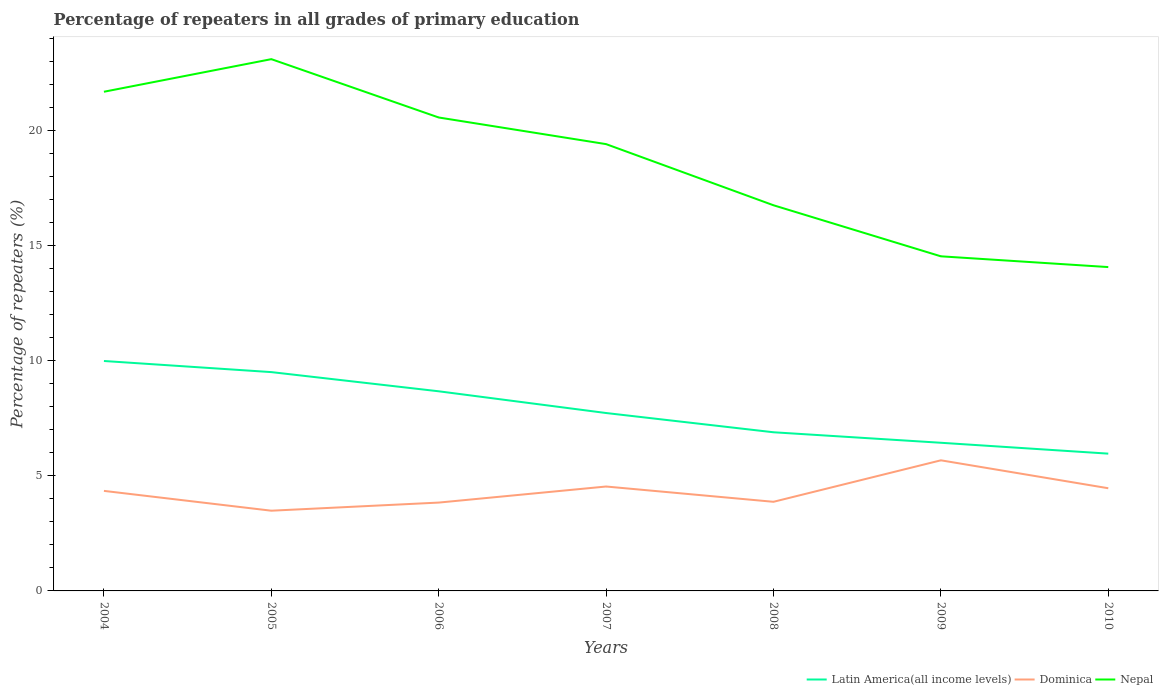How many different coloured lines are there?
Your answer should be very brief. 3. Is the number of lines equal to the number of legend labels?
Provide a succinct answer. Yes. Across all years, what is the maximum percentage of repeaters in Dominica?
Your answer should be compact. 3.48. In which year was the percentage of repeaters in Latin America(all income levels) maximum?
Your response must be concise. 2010. What is the total percentage of repeaters in Dominica in the graph?
Your response must be concise. 0.47. What is the difference between the highest and the second highest percentage of repeaters in Nepal?
Provide a succinct answer. 9.03. What is the difference between the highest and the lowest percentage of repeaters in Latin America(all income levels)?
Keep it short and to the point. 3. How many lines are there?
Your response must be concise. 3. How many years are there in the graph?
Make the answer very short. 7. What is the difference between two consecutive major ticks on the Y-axis?
Your answer should be compact. 5. Does the graph contain any zero values?
Provide a succinct answer. No. Where does the legend appear in the graph?
Your answer should be very brief. Bottom right. How many legend labels are there?
Give a very brief answer. 3. How are the legend labels stacked?
Provide a short and direct response. Horizontal. What is the title of the graph?
Your response must be concise. Percentage of repeaters in all grades of primary education. What is the label or title of the X-axis?
Provide a succinct answer. Years. What is the label or title of the Y-axis?
Keep it short and to the point. Percentage of repeaters (%). What is the Percentage of repeaters (%) in Latin America(all income levels) in 2004?
Your response must be concise. 9.99. What is the Percentage of repeaters (%) in Dominica in 2004?
Provide a succinct answer. 4.35. What is the Percentage of repeaters (%) in Nepal in 2004?
Offer a terse response. 21.68. What is the Percentage of repeaters (%) of Latin America(all income levels) in 2005?
Offer a very short reply. 9.51. What is the Percentage of repeaters (%) in Dominica in 2005?
Provide a succinct answer. 3.48. What is the Percentage of repeaters (%) in Nepal in 2005?
Ensure brevity in your answer.  23.1. What is the Percentage of repeaters (%) in Latin America(all income levels) in 2006?
Offer a very short reply. 8.67. What is the Percentage of repeaters (%) in Dominica in 2006?
Your response must be concise. 3.84. What is the Percentage of repeaters (%) of Nepal in 2006?
Ensure brevity in your answer.  20.57. What is the Percentage of repeaters (%) in Latin America(all income levels) in 2007?
Offer a terse response. 7.73. What is the Percentage of repeaters (%) of Dominica in 2007?
Keep it short and to the point. 4.54. What is the Percentage of repeaters (%) in Nepal in 2007?
Ensure brevity in your answer.  19.41. What is the Percentage of repeaters (%) of Latin America(all income levels) in 2008?
Ensure brevity in your answer.  6.89. What is the Percentage of repeaters (%) in Dominica in 2008?
Your answer should be compact. 3.87. What is the Percentage of repeaters (%) in Nepal in 2008?
Ensure brevity in your answer.  16.75. What is the Percentage of repeaters (%) of Latin America(all income levels) in 2009?
Your response must be concise. 6.44. What is the Percentage of repeaters (%) in Dominica in 2009?
Keep it short and to the point. 5.67. What is the Percentage of repeaters (%) of Nepal in 2009?
Give a very brief answer. 14.54. What is the Percentage of repeaters (%) of Latin America(all income levels) in 2010?
Ensure brevity in your answer.  5.96. What is the Percentage of repeaters (%) of Dominica in 2010?
Offer a terse response. 4.46. What is the Percentage of repeaters (%) of Nepal in 2010?
Offer a terse response. 14.07. Across all years, what is the maximum Percentage of repeaters (%) in Latin America(all income levels)?
Offer a very short reply. 9.99. Across all years, what is the maximum Percentage of repeaters (%) of Dominica?
Provide a short and direct response. 5.67. Across all years, what is the maximum Percentage of repeaters (%) of Nepal?
Your answer should be compact. 23.1. Across all years, what is the minimum Percentage of repeaters (%) of Latin America(all income levels)?
Provide a short and direct response. 5.96. Across all years, what is the minimum Percentage of repeaters (%) of Dominica?
Make the answer very short. 3.48. Across all years, what is the minimum Percentage of repeaters (%) of Nepal?
Offer a very short reply. 14.07. What is the total Percentage of repeaters (%) in Latin America(all income levels) in the graph?
Your answer should be very brief. 55.19. What is the total Percentage of repeaters (%) in Dominica in the graph?
Provide a short and direct response. 30.21. What is the total Percentage of repeaters (%) of Nepal in the graph?
Provide a succinct answer. 130.12. What is the difference between the Percentage of repeaters (%) in Latin America(all income levels) in 2004 and that in 2005?
Make the answer very short. 0.48. What is the difference between the Percentage of repeaters (%) in Dominica in 2004 and that in 2005?
Your response must be concise. 0.86. What is the difference between the Percentage of repeaters (%) of Nepal in 2004 and that in 2005?
Keep it short and to the point. -1.42. What is the difference between the Percentage of repeaters (%) in Latin America(all income levels) in 2004 and that in 2006?
Keep it short and to the point. 1.32. What is the difference between the Percentage of repeaters (%) of Dominica in 2004 and that in 2006?
Make the answer very short. 0.51. What is the difference between the Percentage of repeaters (%) of Nepal in 2004 and that in 2006?
Keep it short and to the point. 1.12. What is the difference between the Percentage of repeaters (%) of Latin America(all income levels) in 2004 and that in 2007?
Make the answer very short. 2.26. What is the difference between the Percentage of repeaters (%) of Dominica in 2004 and that in 2007?
Give a very brief answer. -0.19. What is the difference between the Percentage of repeaters (%) in Nepal in 2004 and that in 2007?
Offer a terse response. 2.28. What is the difference between the Percentage of repeaters (%) in Latin America(all income levels) in 2004 and that in 2008?
Keep it short and to the point. 3.1. What is the difference between the Percentage of repeaters (%) in Dominica in 2004 and that in 2008?
Offer a terse response. 0.47. What is the difference between the Percentage of repeaters (%) in Nepal in 2004 and that in 2008?
Offer a very short reply. 4.93. What is the difference between the Percentage of repeaters (%) in Latin America(all income levels) in 2004 and that in 2009?
Your answer should be compact. 3.55. What is the difference between the Percentage of repeaters (%) in Dominica in 2004 and that in 2009?
Your response must be concise. -1.33. What is the difference between the Percentage of repeaters (%) in Nepal in 2004 and that in 2009?
Your answer should be compact. 7.15. What is the difference between the Percentage of repeaters (%) of Latin America(all income levels) in 2004 and that in 2010?
Your response must be concise. 4.02. What is the difference between the Percentage of repeaters (%) in Dominica in 2004 and that in 2010?
Make the answer very short. -0.11. What is the difference between the Percentage of repeaters (%) in Nepal in 2004 and that in 2010?
Provide a succinct answer. 7.62. What is the difference between the Percentage of repeaters (%) of Latin America(all income levels) in 2005 and that in 2006?
Your response must be concise. 0.83. What is the difference between the Percentage of repeaters (%) of Dominica in 2005 and that in 2006?
Your answer should be very brief. -0.35. What is the difference between the Percentage of repeaters (%) of Nepal in 2005 and that in 2006?
Make the answer very short. 2.53. What is the difference between the Percentage of repeaters (%) of Latin America(all income levels) in 2005 and that in 2007?
Give a very brief answer. 1.78. What is the difference between the Percentage of repeaters (%) in Dominica in 2005 and that in 2007?
Offer a very short reply. -1.05. What is the difference between the Percentage of repeaters (%) in Nepal in 2005 and that in 2007?
Your response must be concise. 3.69. What is the difference between the Percentage of repeaters (%) of Latin America(all income levels) in 2005 and that in 2008?
Your answer should be very brief. 2.61. What is the difference between the Percentage of repeaters (%) in Dominica in 2005 and that in 2008?
Provide a succinct answer. -0.39. What is the difference between the Percentage of repeaters (%) in Nepal in 2005 and that in 2008?
Your answer should be very brief. 6.35. What is the difference between the Percentage of repeaters (%) of Latin America(all income levels) in 2005 and that in 2009?
Your answer should be very brief. 3.07. What is the difference between the Percentage of repeaters (%) of Dominica in 2005 and that in 2009?
Provide a short and direct response. -2.19. What is the difference between the Percentage of repeaters (%) of Nepal in 2005 and that in 2009?
Make the answer very short. 8.57. What is the difference between the Percentage of repeaters (%) in Latin America(all income levels) in 2005 and that in 2010?
Your answer should be compact. 3.54. What is the difference between the Percentage of repeaters (%) in Dominica in 2005 and that in 2010?
Your answer should be compact. -0.98. What is the difference between the Percentage of repeaters (%) of Nepal in 2005 and that in 2010?
Provide a succinct answer. 9.03. What is the difference between the Percentage of repeaters (%) of Latin America(all income levels) in 2006 and that in 2007?
Give a very brief answer. 0.94. What is the difference between the Percentage of repeaters (%) of Dominica in 2006 and that in 2007?
Ensure brevity in your answer.  -0.7. What is the difference between the Percentage of repeaters (%) in Nepal in 2006 and that in 2007?
Provide a succinct answer. 1.16. What is the difference between the Percentage of repeaters (%) in Latin America(all income levels) in 2006 and that in 2008?
Offer a terse response. 1.78. What is the difference between the Percentage of repeaters (%) of Dominica in 2006 and that in 2008?
Offer a very short reply. -0.03. What is the difference between the Percentage of repeaters (%) of Nepal in 2006 and that in 2008?
Your answer should be very brief. 3.81. What is the difference between the Percentage of repeaters (%) in Latin America(all income levels) in 2006 and that in 2009?
Offer a very short reply. 2.24. What is the difference between the Percentage of repeaters (%) in Dominica in 2006 and that in 2009?
Offer a terse response. -1.84. What is the difference between the Percentage of repeaters (%) in Nepal in 2006 and that in 2009?
Offer a very short reply. 6.03. What is the difference between the Percentage of repeaters (%) of Latin America(all income levels) in 2006 and that in 2010?
Offer a terse response. 2.71. What is the difference between the Percentage of repeaters (%) in Dominica in 2006 and that in 2010?
Offer a terse response. -0.62. What is the difference between the Percentage of repeaters (%) of Nepal in 2006 and that in 2010?
Your answer should be compact. 6.5. What is the difference between the Percentage of repeaters (%) of Latin America(all income levels) in 2007 and that in 2008?
Keep it short and to the point. 0.84. What is the difference between the Percentage of repeaters (%) in Dominica in 2007 and that in 2008?
Your response must be concise. 0.66. What is the difference between the Percentage of repeaters (%) in Nepal in 2007 and that in 2008?
Offer a terse response. 2.66. What is the difference between the Percentage of repeaters (%) of Latin America(all income levels) in 2007 and that in 2009?
Make the answer very short. 1.29. What is the difference between the Percentage of repeaters (%) in Dominica in 2007 and that in 2009?
Offer a very short reply. -1.14. What is the difference between the Percentage of repeaters (%) of Nepal in 2007 and that in 2009?
Ensure brevity in your answer.  4.87. What is the difference between the Percentage of repeaters (%) in Latin America(all income levels) in 2007 and that in 2010?
Your response must be concise. 1.76. What is the difference between the Percentage of repeaters (%) of Dominica in 2007 and that in 2010?
Provide a short and direct response. 0.07. What is the difference between the Percentage of repeaters (%) in Nepal in 2007 and that in 2010?
Offer a very short reply. 5.34. What is the difference between the Percentage of repeaters (%) in Latin America(all income levels) in 2008 and that in 2009?
Offer a terse response. 0.46. What is the difference between the Percentage of repeaters (%) of Dominica in 2008 and that in 2009?
Make the answer very short. -1.8. What is the difference between the Percentage of repeaters (%) of Nepal in 2008 and that in 2009?
Offer a terse response. 2.22. What is the difference between the Percentage of repeaters (%) of Latin America(all income levels) in 2008 and that in 2010?
Give a very brief answer. 0.93. What is the difference between the Percentage of repeaters (%) of Dominica in 2008 and that in 2010?
Provide a short and direct response. -0.59. What is the difference between the Percentage of repeaters (%) in Nepal in 2008 and that in 2010?
Provide a succinct answer. 2.69. What is the difference between the Percentage of repeaters (%) of Latin America(all income levels) in 2009 and that in 2010?
Your response must be concise. 0.47. What is the difference between the Percentage of repeaters (%) of Dominica in 2009 and that in 2010?
Your response must be concise. 1.21. What is the difference between the Percentage of repeaters (%) of Nepal in 2009 and that in 2010?
Give a very brief answer. 0.47. What is the difference between the Percentage of repeaters (%) of Latin America(all income levels) in 2004 and the Percentage of repeaters (%) of Dominica in 2005?
Your answer should be very brief. 6.5. What is the difference between the Percentage of repeaters (%) of Latin America(all income levels) in 2004 and the Percentage of repeaters (%) of Nepal in 2005?
Offer a terse response. -13.11. What is the difference between the Percentage of repeaters (%) of Dominica in 2004 and the Percentage of repeaters (%) of Nepal in 2005?
Keep it short and to the point. -18.76. What is the difference between the Percentage of repeaters (%) of Latin America(all income levels) in 2004 and the Percentage of repeaters (%) of Dominica in 2006?
Give a very brief answer. 6.15. What is the difference between the Percentage of repeaters (%) of Latin America(all income levels) in 2004 and the Percentage of repeaters (%) of Nepal in 2006?
Keep it short and to the point. -10.58. What is the difference between the Percentage of repeaters (%) in Dominica in 2004 and the Percentage of repeaters (%) in Nepal in 2006?
Your response must be concise. -16.22. What is the difference between the Percentage of repeaters (%) in Latin America(all income levels) in 2004 and the Percentage of repeaters (%) in Dominica in 2007?
Offer a terse response. 5.45. What is the difference between the Percentage of repeaters (%) of Latin America(all income levels) in 2004 and the Percentage of repeaters (%) of Nepal in 2007?
Make the answer very short. -9.42. What is the difference between the Percentage of repeaters (%) in Dominica in 2004 and the Percentage of repeaters (%) in Nepal in 2007?
Offer a terse response. -15.06. What is the difference between the Percentage of repeaters (%) of Latin America(all income levels) in 2004 and the Percentage of repeaters (%) of Dominica in 2008?
Your answer should be very brief. 6.12. What is the difference between the Percentage of repeaters (%) in Latin America(all income levels) in 2004 and the Percentage of repeaters (%) in Nepal in 2008?
Offer a very short reply. -6.76. What is the difference between the Percentage of repeaters (%) in Dominica in 2004 and the Percentage of repeaters (%) in Nepal in 2008?
Provide a succinct answer. -12.41. What is the difference between the Percentage of repeaters (%) in Latin America(all income levels) in 2004 and the Percentage of repeaters (%) in Dominica in 2009?
Your answer should be very brief. 4.31. What is the difference between the Percentage of repeaters (%) in Latin America(all income levels) in 2004 and the Percentage of repeaters (%) in Nepal in 2009?
Give a very brief answer. -4.55. What is the difference between the Percentage of repeaters (%) of Dominica in 2004 and the Percentage of repeaters (%) of Nepal in 2009?
Provide a succinct answer. -10.19. What is the difference between the Percentage of repeaters (%) in Latin America(all income levels) in 2004 and the Percentage of repeaters (%) in Dominica in 2010?
Your answer should be very brief. 5.53. What is the difference between the Percentage of repeaters (%) of Latin America(all income levels) in 2004 and the Percentage of repeaters (%) of Nepal in 2010?
Keep it short and to the point. -4.08. What is the difference between the Percentage of repeaters (%) in Dominica in 2004 and the Percentage of repeaters (%) in Nepal in 2010?
Provide a succinct answer. -9.72. What is the difference between the Percentage of repeaters (%) in Latin America(all income levels) in 2005 and the Percentage of repeaters (%) in Dominica in 2006?
Keep it short and to the point. 5.67. What is the difference between the Percentage of repeaters (%) of Latin America(all income levels) in 2005 and the Percentage of repeaters (%) of Nepal in 2006?
Make the answer very short. -11.06. What is the difference between the Percentage of repeaters (%) in Dominica in 2005 and the Percentage of repeaters (%) in Nepal in 2006?
Your response must be concise. -17.08. What is the difference between the Percentage of repeaters (%) of Latin America(all income levels) in 2005 and the Percentage of repeaters (%) of Dominica in 2007?
Give a very brief answer. 4.97. What is the difference between the Percentage of repeaters (%) of Latin America(all income levels) in 2005 and the Percentage of repeaters (%) of Nepal in 2007?
Your answer should be compact. -9.9. What is the difference between the Percentage of repeaters (%) of Dominica in 2005 and the Percentage of repeaters (%) of Nepal in 2007?
Keep it short and to the point. -15.92. What is the difference between the Percentage of repeaters (%) of Latin America(all income levels) in 2005 and the Percentage of repeaters (%) of Dominica in 2008?
Provide a short and direct response. 5.63. What is the difference between the Percentage of repeaters (%) in Latin America(all income levels) in 2005 and the Percentage of repeaters (%) in Nepal in 2008?
Ensure brevity in your answer.  -7.25. What is the difference between the Percentage of repeaters (%) of Dominica in 2005 and the Percentage of repeaters (%) of Nepal in 2008?
Make the answer very short. -13.27. What is the difference between the Percentage of repeaters (%) of Latin America(all income levels) in 2005 and the Percentage of repeaters (%) of Dominica in 2009?
Your answer should be very brief. 3.83. What is the difference between the Percentage of repeaters (%) in Latin America(all income levels) in 2005 and the Percentage of repeaters (%) in Nepal in 2009?
Your answer should be compact. -5.03. What is the difference between the Percentage of repeaters (%) in Dominica in 2005 and the Percentage of repeaters (%) in Nepal in 2009?
Give a very brief answer. -11.05. What is the difference between the Percentage of repeaters (%) in Latin America(all income levels) in 2005 and the Percentage of repeaters (%) in Dominica in 2010?
Your response must be concise. 5.04. What is the difference between the Percentage of repeaters (%) in Latin America(all income levels) in 2005 and the Percentage of repeaters (%) in Nepal in 2010?
Offer a terse response. -4.56. What is the difference between the Percentage of repeaters (%) in Dominica in 2005 and the Percentage of repeaters (%) in Nepal in 2010?
Offer a terse response. -10.58. What is the difference between the Percentage of repeaters (%) of Latin America(all income levels) in 2006 and the Percentage of repeaters (%) of Dominica in 2007?
Your answer should be compact. 4.14. What is the difference between the Percentage of repeaters (%) in Latin America(all income levels) in 2006 and the Percentage of repeaters (%) in Nepal in 2007?
Give a very brief answer. -10.74. What is the difference between the Percentage of repeaters (%) of Dominica in 2006 and the Percentage of repeaters (%) of Nepal in 2007?
Offer a terse response. -15.57. What is the difference between the Percentage of repeaters (%) of Latin America(all income levels) in 2006 and the Percentage of repeaters (%) of Dominica in 2008?
Provide a short and direct response. 4.8. What is the difference between the Percentage of repeaters (%) in Latin America(all income levels) in 2006 and the Percentage of repeaters (%) in Nepal in 2008?
Provide a short and direct response. -8.08. What is the difference between the Percentage of repeaters (%) of Dominica in 2006 and the Percentage of repeaters (%) of Nepal in 2008?
Provide a short and direct response. -12.92. What is the difference between the Percentage of repeaters (%) of Latin America(all income levels) in 2006 and the Percentage of repeaters (%) of Dominica in 2009?
Keep it short and to the point. 3. What is the difference between the Percentage of repeaters (%) of Latin America(all income levels) in 2006 and the Percentage of repeaters (%) of Nepal in 2009?
Provide a succinct answer. -5.86. What is the difference between the Percentage of repeaters (%) of Dominica in 2006 and the Percentage of repeaters (%) of Nepal in 2009?
Ensure brevity in your answer.  -10.7. What is the difference between the Percentage of repeaters (%) of Latin America(all income levels) in 2006 and the Percentage of repeaters (%) of Dominica in 2010?
Your response must be concise. 4.21. What is the difference between the Percentage of repeaters (%) in Latin America(all income levels) in 2006 and the Percentage of repeaters (%) in Nepal in 2010?
Provide a succinct answer. -5.4. What is the difference between the Percentage of repeaters (%) in Dominica in 2006 and the Percentage of repeaters (%) in Nepal in 2010?
Make the answer very short. -10.23. What is the difference between the Percentage of repeaters (%) in Latin America(all income levels) in 2007 and the Percentage of repeaters (%) in Dominica in 2008?
Your response must be concise. 3.86. What is the difference between the Percentage of repeaters (%) in Latin America(all income levels) in 2007 and the Percentage of repeaters (%) in Nepal in 2008?
Keep it short and to the point. -9.03. What is the difference between the Percentage of repeaters (%) of Dominica in 2007 and the Percentage of repeaters (%) of Nepal in 2008?
Keep it short and to the point. -12.22. What is the difference between the Percentage of repeaters (%) in Latin America(all income levels) in 2007 and the Percentage of repeaters (%) in Dominica in 2009?
Ensure brevity in your answer.  2.05. What is the difference between the Percentage of repeaters (%) of Latin America(all income levels) in 2007 and the Percentage of repeaters (%) of Nepal in 2009?
Your answer should be compact. -6.81. What is the difference between the Percentage of repeaters (%) of Dominica in 2007 and the Percentage of repeaters (%) of Nepal in 2009?
Give a very brief answer. -10. What is the difference between the Percentage of repeaters (%) of Latin America(all income levels) in 2007 and the Percentage of repeaters (%) of Dominica in 2010?
Your answer should be very brief. 3.27. What is the difference between the Percentage of repeaters (%) of Latin America(all income levels) in 2007 and the Percentage of repeaters (%) of Nepal in 2010?
Make the answer very short. -6.34. What is the difference between the Percentage of repeaters (%) of Dominica in 2007 and the Percentage of repeaters (%) of Nepal in 2010?
Give a very brief answer. -9.53. What is the difference between the Percentage of repeaters (%) of Latin America(all income levels) in 2008 and the Percentage of repeaters (%) of Dominica in 2009?
Provide a short and direct response. 1.22. What is the difference between the Percentage of repeaters (%) in Latin America(all income levels) in 2008 and the Percentage of repeaters (%) in Nepal in 2009?
Provide a succinct answer. -7.64. What is the difference between the Percentage of repeaters (%) in Dominica in 2008 and the Percentage of repeaters (%) in Nepal in 2009?
Give a very brief answer. -10.66. What is the difference between the Percentage of repeaters (%) of Latin America(all income levels) in 2008 and the Percentage of repeaters (%) of Dominica in 2010?
Offer a terse response. 2.43. What is the difference between the Percentage of repeaters (%) in Latin America(all income levels) in 2008 and the Percentage of repeaters (%) in Nepal in 2010?
Provide a succinct answer. -7.18. What is the difference between the Percentage of repeaters (%) of Dominica in 2008 and the Percentage of repeaters (%) of Nepal in 2010?
Your answer should be very brief. -10.2. What is the difference between the Percentage of repeaters (%) of Latin America(all income levels) in 2009 and the Percentage of repeaters (%) of Dominica in 2010?
Ensure brevity in your answer.  1.98. What is the difference between the Percentage of repeaters (%) of Latin America(all income levels) in 2009 and the Percentage of repeaters (%) of Nepal in 2010?
Provide a short and direct response. -7.63. What is the difference between the Percentage of repeaters (%) in Dominica in 2009 and the Percentage of repeaters (%) in Nepal in 2010?
Offer a very short reply. -8.39. What is the average Percentage of repeaters (%) in Latin America(all income levels) per year?
Offer a very short reply. 7.88. What is the average Percentage of repeaters (%) of Dominica per year?
Make the answer very short. 4.32. What is the average Percentage of repeaters (%) of Nepal per year?
Offer a very short reply. 18.59. In the year 2004, what is the difference between the Percentage of repeaters (%) of Latin America(all income levels) and Percentage of repeaters (%) of Dominica?
Ensure brevity in your answer.  5.64. In the year 2004, what is the difference between the Percentage of repeaters (%) of Latin America(all income levels) and Percentage of repeaters (%) of Nepal?
Give a very brief answer. -11.7. In the year 2004, what is the difference between the Percentage of repeaters (%) in Dominica and Percentage of repeaters (%) in Nepal?
Your answer should be compact. -17.34. In the year 2005, what is the difference between the Percentage of repeaters (%) in Latin America(all income levels) and Percentage of repeaters (%) in Dominica?
Offer a terse response. 6.02. In the year 2005, what is the difference between the Percentage of repeaters (%) of Latin America(all income levels) and Percentage of repeaters (%) of Nepal?
Ensure brevity in your answer.  -13.6. In the year 2005, what is the difference between the Percentage of repeaters (%) in Dominica and Percentage of repeaters (%) in Nepal?
Your answer should be compact. -19.62. In the year 2006, what is the difference between the Percentage of repeaters (%) in Latin America(all income levels) and Percentage of repeaters (%) in Dominica?
Your response must be concise. 4.83. In the year 2006, what is the difference between the Percentage of repeaters (%) of Latin America(all income levels) and Percentage of repeaters (%) of Nepal?
Your answer should be very brief. -11.89. In the year 2006, what is the difference between the Percentage of repeaters (%) of Dominica and Percentage of repeaters (%) of Nepal?
Provide a short and direct response. -16.73. In the year 2007, what is the difference between the Percentage of repeaters (%) of Latin America(all income levels) and Percentage of repeaters (%) of Dominica?
Make the answer very short. 3.19. In the year 2007, what is the difference between the Percentage of repeaters (%) in Latin America(all income levels) and Percentage of repeaters (%) in Nepal?
Give a very brief answer. -11.68. In the year 2007, what is the difference between the Percentage of repeaters (%) in Dominica and Percentage of repeaters (%) in Nepal?
Provide a succinct answer. -14.87. In the year 2008, what is the difference between the Percentage of repeaters (%) in Latin America(all income levels) and Percentage of repeaters (%) in Dominica?
Keep it short and to the point. 3.02. In the year 2008, what is the difference between the Percentage of repeaters (%) of Latin America(all income levels) and Percentage of repeaters (%) of Nepal?
Make the answer very short. -9.86. In the year 2008, what is the difference between the Percentage of repeaters (%) of Dominica and Percentage of repeaters (%) of Nepal?
Offer a very short reply. -12.88. In the year 2009, what is the difference between the Percentage of repeaters (%) in Latin America(all income levels) and Percentage of repeaters (%) in Dominica?
Offer a very short reply. 0.76. In the year 2009, what is the difference between the Percentage of repeaters (%) in Latin America(all income levels) and Percentage of repeaters (%) in Nepal?
Your answer should be compact. -8.1. In the year 2009, what is the difference between the Percentage of repeaters (%) in Dominica and Percentage of repeaters (%) in Nepal?
Provide a short and direct response. -8.86. In the year 2010, what is the difference between the Percentage of repeaters (%) in Latin America(all income levels) and Percentage of repeaters (%) in Dominica?
Your answer should be very brief. 1.5. In the year 2010, what is the difference between the Percentage of repeaters (%) in Latin America(all income levels) and Percentage of repeaters (%) in Nepal?
Give a very brief answer. -8.1. In the year 2010, what is the difference between the Percentage of repeaters (%) in Dominica and Percentage of repeaters (%) in Nepal?
Ensure brevity in your answer.  -9.61. What is the ratio of the Percentage of repeaters (%) of Latin America(all income levels) in 2004 to that in 2005?
Your response must be concise. 1.05. What is the ratio of the Percentage of repeaters (%) of Dominica in 2004 to that in 2005?
Keep it short and to the point. 1.25. What is the ratio of the Percentage of repeaters (%) in Nepal in 2004 to that in 2005?
Provide a short and direct response. 0.94. What is the ratio of the Percentage of repeaters (%) of Latin America(all income levels) in 2004 to that in 2006?
Your answer should be compact. 1.15. What is the ratio of the Percentage of repeaters (%) of Dominica in 2004 to that in 2006?
Provide a succinct answer. 1.13. What is the ratio of the Percentage of repeaters (%) in Nepal in 2004 to that in 2006?
Your answer should be very brief. 1.05. What is the ratio of the Percentage of repeaters (%) of Latin America(all income levels) in 2004 to that in 2007?
Offer a very short reply. 1.29. What is the ratio of the Percentage of repeaters (%) of Dominica in 2004 to that in 2007?
Your response must be concise. 0.96. What is the ratio of the Percentage of repeaters (%) in Nepal in 2004 to that in 2007?
Make the answer very short. 1.12. What is the ratio of the Percentage of repeaters (%) of Latin America(all income levels) in 2004 to that in 2008?
Your response must be concise. 1.45. What is the ratio of the Percentage of repeaters (%) in Dominica in 2004 to that in 2008?
Make the answer very short. 1.12. What is the ratio of the Percentage of repeaters (%) in Nepal in 2004 to that in 2008?
Provide a short and direct response. 1.29. What is the ratio of the Percentage of repeaters (%) in Latin America(all income levels) in 2004 to that in 2009?
Make the answer very short. 1.55. What is the ratio of the Percentage of repeaters (%) in Dominica in 2004 to that in 2009?
Your response must be concise. 0.77. What is the ratio of the Percentage of repeaters (%) of Nepal in 2004 to that in 2009?
Offer a very short reply. 1.49. What is the ratio of the Percentage of repeaters (%) in Latin America(all income levels) in 2004 to that in 2010?
Ensure brevity in your answer.  1.67. What is the ratio of the Percentage of repeaters (%) in Dominica in 2004 to that in 2010?
Keep it short and to the point. 0.97. What is the ratio of the Percentage of repeaters (%) in Nepal in 2004 to that in 2010?
Offer a terse response. 1.54. What is the ratio of the Percentage of repeaters (%) in Latin America(all income levels) in 2005 to that in 2006?
Your answer should be very brief. 1.1. What is the ratio of the Percentage of repeaters (%) in Dominica in 2005 to that in 2006?
Give a very brief answer. 0.91. What is the ratio of the Percentage of repeaters (%) of Nepal in 2005 to that in 2006?
Your answer should be very brief. 1.12. What is the ratio of the Percentage of repeaters (%) of Latin America(all income levels) in 2005 to that in 2007?
Give a very brief answer. 1.23. What is the ratio of the Percentage of repeaters (%) in Dominica in 2005 to that in 2007?
Provide a short and direct response. 0.77. What is the ratio of the Percentage of repeaters (%) of Nepal in 2005 to that in 2007?
Your response must be concise. 1.19. What is the ratio of the Percentage of repeaters (%) in Latin America(all income levels) in 2005 to that in 2008?
Your answer should be compact. 1.38. What is the ratio of the Percentage of repeaters (%) of Dominica in 2005 to that in 2008?
Offer a very short reply. 0.9. What is the ratio of the Percentage of repeaters (%) in Nepal in 2005 to that in 2008?
Offer a very short reply. 1.38. What is the ratio of the Percentage of repeaters (%) of Latin America(all income levels) in 2005 to that in 2009?
Provide a short and direct response. 1.48. What is the ratio of the Percentage of repeaters (%) of Dominica in 2005 to that in 2009?
Give a very brief answer. 0.61. What is the ratio of the Percentage of repeaters (%) in Nepal in 2005 to that in 2009?
Offer a terse response. 1.59. What is the ratio of the Percentage of repeaters (%) of Latin America(all income levels) in 2005 to that in 2010?
Provide a succinct answer. 1.59. What is the ratio of the Percentage of repeaters (%) in Dominica in 2005 to that in 2010?
Offer a very short reply. 0.78. What is the ratio of the Percentage of repeaters (%) in Nepal in 2005 to that in 2010?
Your answer should be very brief. 1.64. What is the ratio of the Percentage of repeaters (%) in Latin America(all income levels) in 2006 to that in 2007?
Offer a very short reply. 1.12. What is the ratio of the Percentage of repeaters (%) in Dominica in 2006 to that in 2007?
Keep it short and to the point. 0.85. What is the ratio of the Percentage of repeaters (%) in Nepal in 2006 to that in 2007?
Offer a very short reply. 1.06. What is the ratio of the Percentage of repeaters (%) in Latin America(all income levels) in 2006 to that in 2008?
Your response must be concise. 1.26. What is the ratio of the Percentage of repeaters (%) in Dominica in 2006 to that in 2008?
Offer a terse response. 0.99. What is the ratio of the Percentage of repeaters (%) of Nepal in 2006 to that in 2008?
Keep it short and to the point. 1.23. What is the ratio of the Percentage of repeaters (%) of Latin America(all income levels) in 2006 to that in 2009?
Provide a succinct answer. 1.35. What is the ratio of the Percentage of repeaters (%) in Dominica in 2006 to that in 2009?
Give a very brief answer. 0.68. What is the ratio of the Percentage of repeaters (%) in Nepal in 2006 to that in 2009?
Keep it short and to the point. 1.41. What is the ratio of the Percentage of repeaters (%) in Latin America(all income levels) in 2006 to that in 2010?
Give a very brief answer. 1.45. What is the ratio of the Percentage of repeaters (%) in Dominica in 2006 to that in 2010?
Give a very brief answer. 0.86. What is the ratio of the Percentage of repeaters (%) of Nepal in 2006 to that in 2010?
Offer a very short reply. 1.46. What is the ratio of the Percentage of repeaters (%) of Latin America(all income levels) in 2007 to that in 2008?
Offer a very short reply. 1.12. What is the ratio of the Percentage of repeaters (%) of Dominica in 2007 to that in 2008?
Your answer should be very brief. 1.17. What is the ratio of the Percentage of repeaters (%) in Nepal in 2007 to that in 2008?
Offer a terse response. 1.16. What is the ratio of the Percentage of repeaters (%) of Latin America(all income levels) in 2007 to that in 2009?
Keep it short and to the point. 1.2. What is the ratio of the Percentage of repeaters (%) in Dominica in 2007 to that in 2009?
Offer a very short reply. 0.8. What is the ratio of the Percentage of repeaters (%) in Nepal in 2007 to that in 2009?
Give a very brief answer. 1.34. What is the ratio of the Percentage of repeaters (%) of Latin America(all income levels) in 2007 to that in 2010?
Give a very brief answer. 1.3. What is the ratio of the Percentage of repeaters (%) in Dominica in 2007 to that in 2010?
Offer a terse response. 1.02. What is the ratio of the Percentage of repeaters (%) of Nepal in 2007 to that in 2010?
Provide a succinct answer. 1.38. What is the ratio of the Percentage of repeaters (%) of Latin America(all income levels) in 2008 to that in 2009?
Give a very brief answer. 1.07. What is the ratio of the Percentage of repeaters (%) in Dominica in 2008 to that in 2009?
Provide a short and direct response. 0.68. What is the ratio of the Percentage of repeaters (%) of Nepal in 2008 to that in 2009?
Your answer should be very brief. 1.15. What is the ratio of the Percentage of repeaters (%) in Latin America(all income levels) in 2008 to that in 2010?
Your answer should be very brief. 1.16. What is the ratio of the Percentage of repeaters (%) of Dominica in 2008 to that in 2010?
Provide a succinct answer. 0.87. What is the ratio of the Percentage of repeaters (%) of Nepal in 2008 to that in 2010?
Provide a succinct answer. 1.19. What is the ratio of the Percentage of repeaters (%) of Latin America(all income levels) in 2009 to that in 2010?
Keep it short and to the point. 1.08. What is the ratio of the Percentage of repeaters (%) in Dominica in 2009 to that in 2010?
Provide a short and direct response. 1.27. What is the ratio of the Percentage of repeaters (%) of Nepal in 2009 to that in 2010?
Provide a short and direct response. 1.03. What is the difference between the highest and the second highest Percentage of repeaters (%) in Latin America(all income levels)?
Provide a short and direct response. 0.48. What is the difference between the highest and the second highest Percentage of repeaters (%) of Dominica?
Make the answer very short. 1.14. What is the difference between the highest and the second highest Percentage of repeaters (%) of Nepal?
Make the answer very short. 1.42. What is the difference between the highest and the lowest Percentage of repeaters (%) in Latin America(all income levels)?
Provide a succinct answer. 4.02. What is the difference between the highest and the lowest Percentage of repeaters (%) in Dominica?
Offer a terse response. 2.19. What is the difference between the highest and the lowest Percentage of repeaters (%) in Nepal?
Keep it short and to the point. 9.03. 